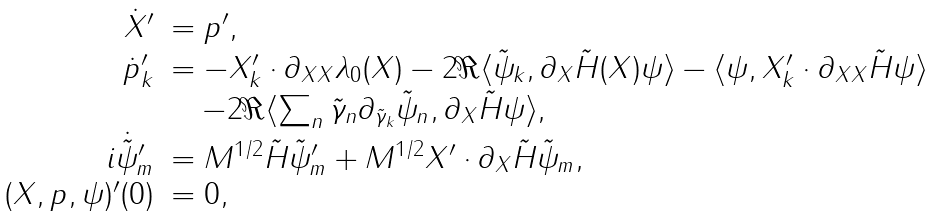<formula> <loc_0><loc_0><loc_500><loc_500>\begin{array} { r l } \dot { X } ^ { \prime } & = p ^ { \prime } , \\ \dot { p } ^ { \prime } _ { k } & = - X ^ { \prime } _ { k } \cdot \partial _ { X X } \lambda _ { 0 } ( X ) - 2 \Re \langle \tilde { \psi } _ { k } , \partial _ { X } \tilde { H } ( X ) \psi \rangle - \langle \psi , X ^ { \prime } _ { k } \cdot \partial _ { X X } \tilde { H } \psi \rangle \\ & \quad - 2 \Re \langle \sum _ { n } \tilde { \gamma } _ { n } \partial _ { \tilde { \gamma } _ { k } } \tilde { \psi } _ { n } , \partial _ { X } \tilde { H } \psi \rangle , \\ i \dot { \tilde { \psi } } ^ { \prime } _ { m } & = M ^ { 1 / 2 } \tilde { H } \tilde { \psi } ^ { \prime } _ { m } + M ^ { 1 / 2 } X ^ { \prime } \cdot \partial _ { X } \tilde { H } \tilde { \psi } _ { m } , \\ ( X , p , \psi ) ^ { \prime } ( 0 ) & = 0 , \\ \end{array}</formula> 